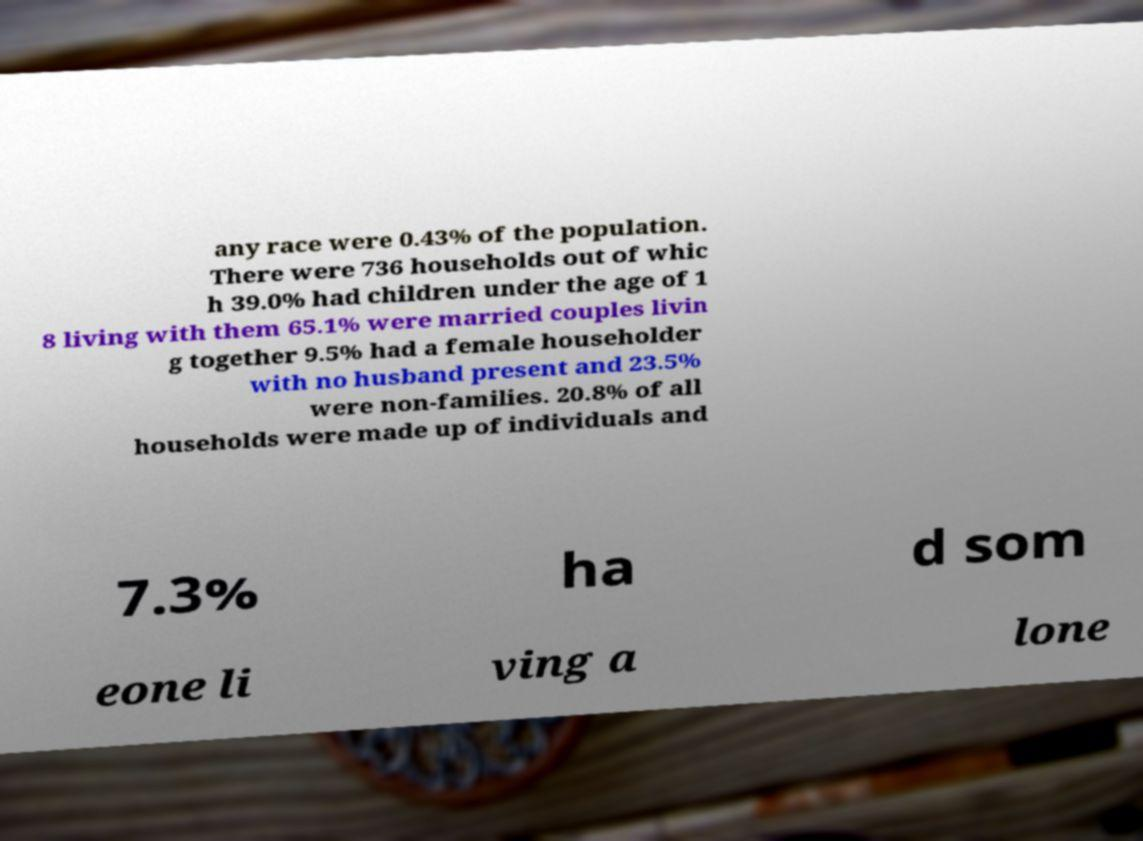For documentation purposes, I need the text within this image transcribed. Could you provide that? any race were 0.43% of the population. There were 736 households out of whic h 39.0% had children under the age of 1 8 living with them 65.1% were married couples livin g together 9.5% had a female householder with no husband present and 23.5% were non-families. 20.8% of all households were made up of individuals and 7.3% ha d som eone li ving a lone 